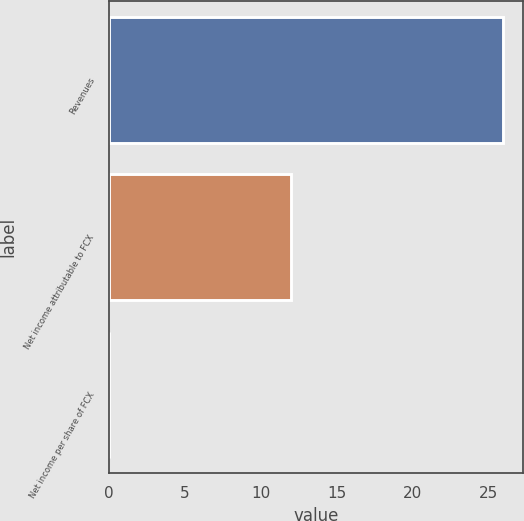Convert chart. <chart><loc_0><loc_0><loc_500><loc_500><bar_chart><fcel>Revenues<fcel>Net income attributable to FCX<fcel>Net income per share of FCX<nl><fcel>26<fcel>12<fcel>0.01<nl></chart> 